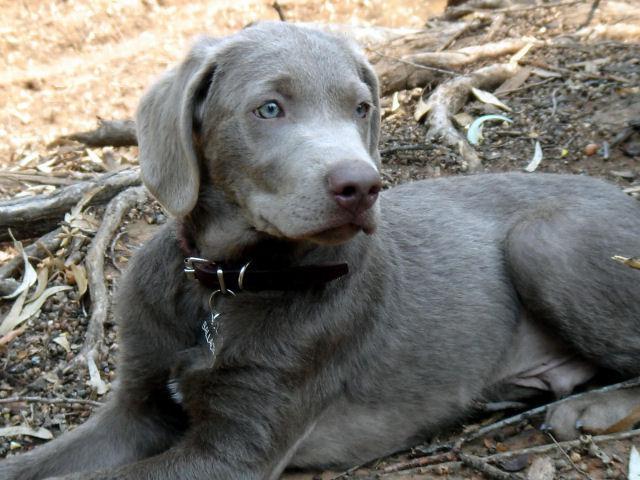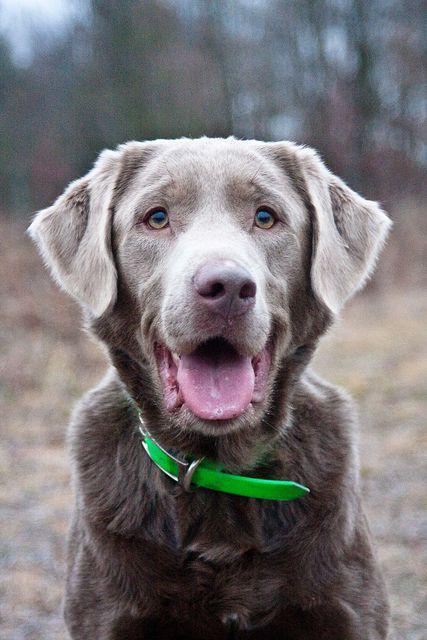The first image is the image on the left, the second image is the image on the right. For the images shown, is this caption "Each image contains exactly one dog, all dogs have grey fur, and one dog has its tongue hanging out." true? Answer yes or no. Yes. The first image is the image on the left, the second image is the image on the right. Assess this claim about the two images: "The right image contains one dog with its tongue hanging out.". Correct or not? Answer yes or no. Yes. 